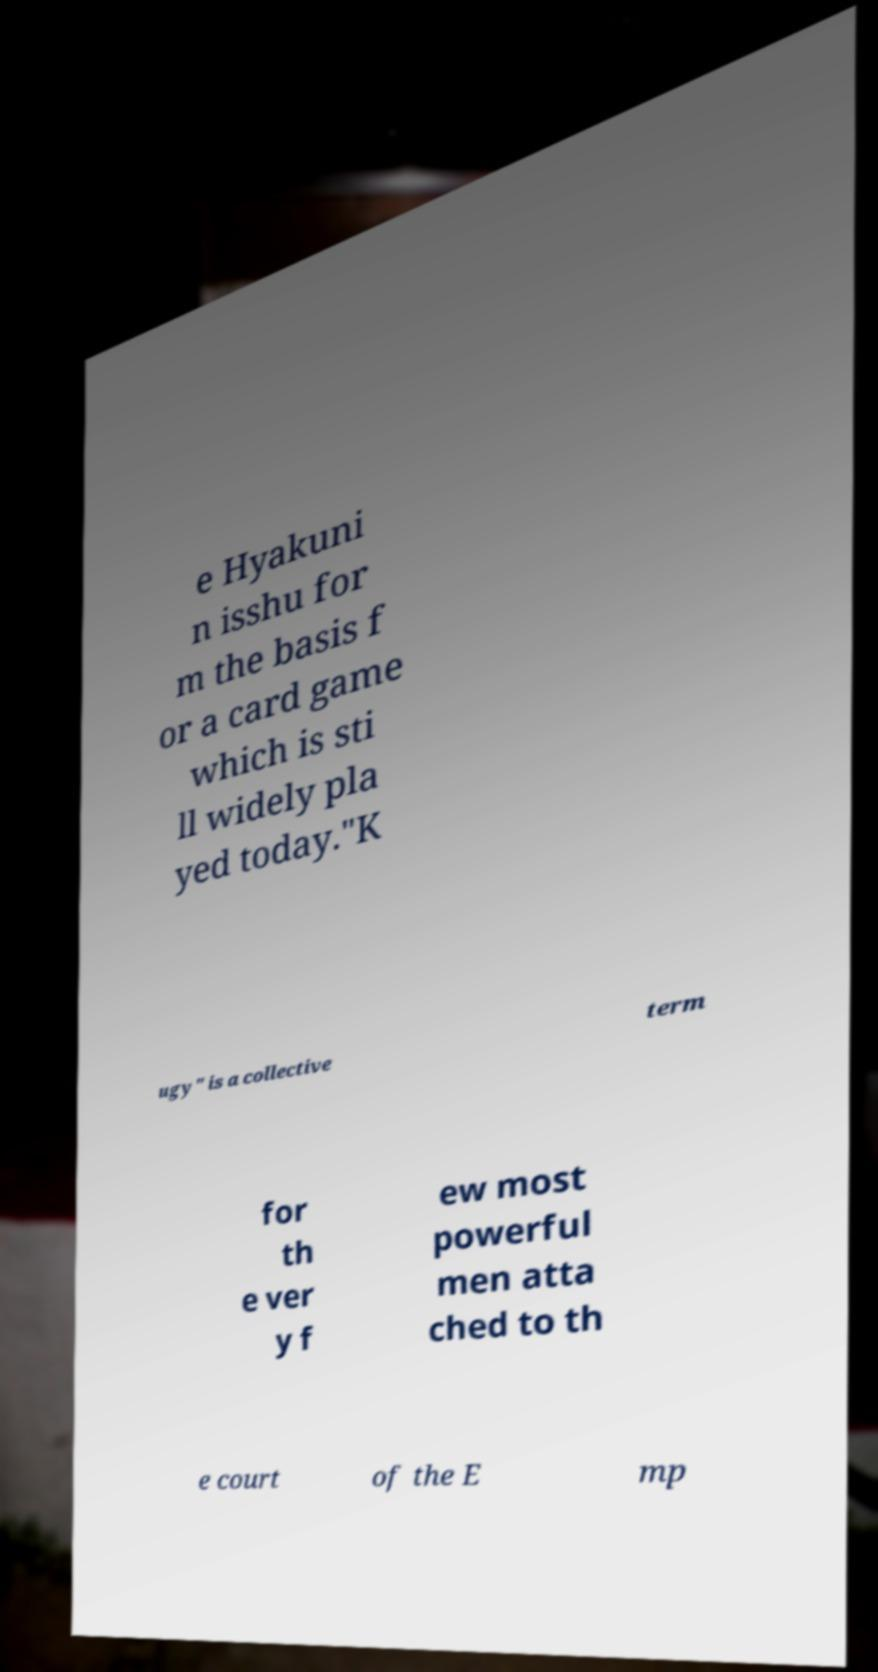I need the written content from this picture converted into text. Can you do that? e Hyakuni n isshu for m the basis f or a card game which is sti ll widely pla yed today."K ugy" is a collective term for th e ver y f ew most powerful men atta ched to th e court of the E mp 